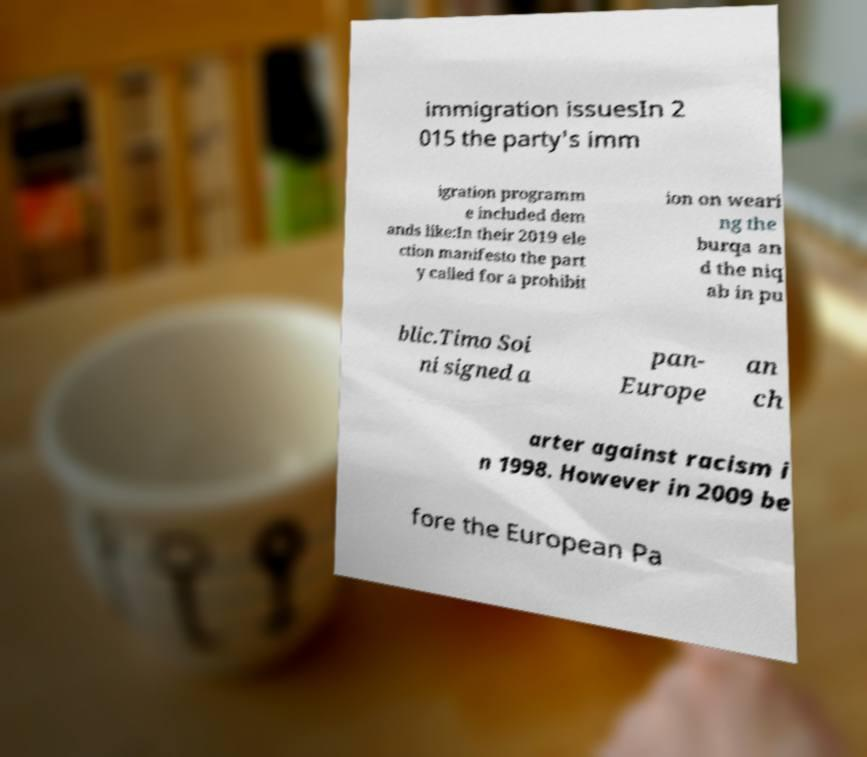There's text embedded in this image that I need extracted. Can you transcribe it verbatim? immigration issuesIn 2 015 the party's imm igration programm e included dem ands like:In their 2019 ele ction manifesto the part y called for a prohibit ion on weari ng the burqa an d the niq ab in pu blic.Timo Soi ni signed a pan- Europe an ch arter against racism i n 1998. However in 2009 be fore the European Pa 